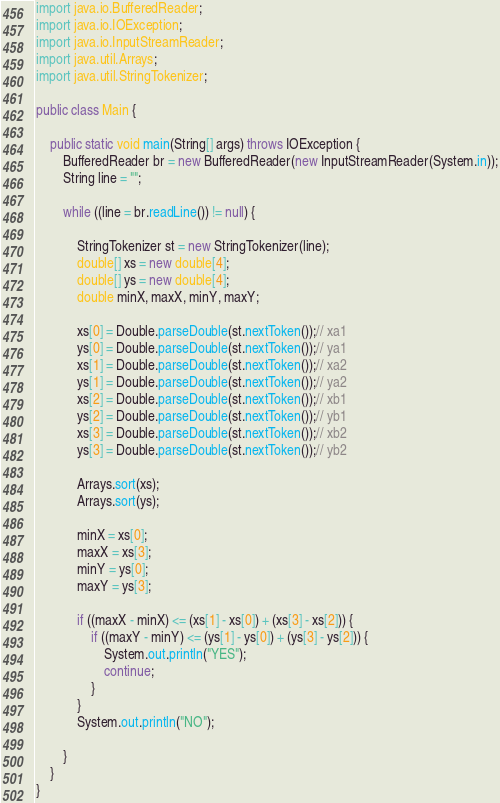Convert code to text. <code><loc_0><loc_0><loc_500><loc_500><_Java_>import java.io.BufferedReader;
import java.io.IOException;
import java.io.InputStreamReader;
import java.util.Arrays;
import java.util.StringTokenizer;

public class Main {

	public static void main(String[] args) throws IOException {
		BufferedReader br = new BufferedReader(new InputStreamReader(System.in));
		String line = "";

		while ((line = br.readLine()) != null) {

			StringTokenizer st = new StringTokenizer(line);
			double[] xs = new double[4];
			double[] ys = new double[4];
			double minX, maxX, minY, maxY;

			xs[0] = Double.parseDouble(st.nextToken());// xa1
			ys[0] = Double.parseDouble(st.nextToken());// ya1
			xs[1] = Double.parseDouble(st.nextToken());// xa2
			ys[1] = Double.parseDouble(st.nextToken());// ya2
			xs[2] = Double.parseDouble(st.nextToken());// xb1
			ys[2] = Double.parseDouble(st.nextToken());// yb1
			xs[3] = Double.parseDouble(st.nextToken());// xb2
			ys[3] = Double.parseDouble(st.nextToken());// yb2

			Arrays.sort(xs);
			Arrays.sort(ys);

			minX = xs[0];
			maxX = xs[3];
			minY = ys[0];
			maxY = ys[3];

			if ((maxX - minX) <= (xs[1] - xs[0]) + (xs[3] - xs[2])) {
				if ((maxY - minY) <= (ys[1] - ys[0]) + (ys[3] - ys[2])) {
					System.out.println("YES");
					continue;
				}
			}
			System.out.println("NO");

		}
	}
}</code> 